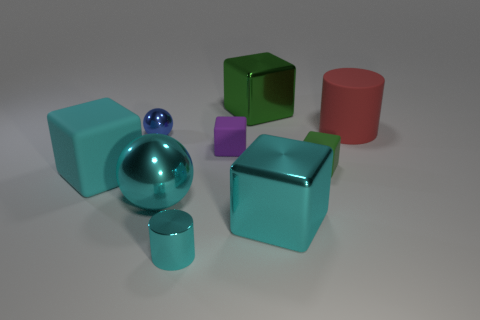Subtract all cyan matte blocks. How many blocks are left? 4 Add 1 metallic cylinders. How many objects exist? 10 Subtract all red cylinders. How many cylinders are left? 1 Subtract 2 balls. How many balls are left? 0 Subtract all brown cubes. Subtract all red cylinders. How many cubes are left? 5 Subtract all red cubes. How many blue balls are left? 1 Subtract all tiny cyan spheres. Subtract all large balls. How many objects are left? 8 Add 5 big red rubber objects. How many big red rubber objects are left? 6 Add 3 tiny objects. How many tiny objects exist? 7 Subtract 1 red cylinders. How many objects are left? 8 